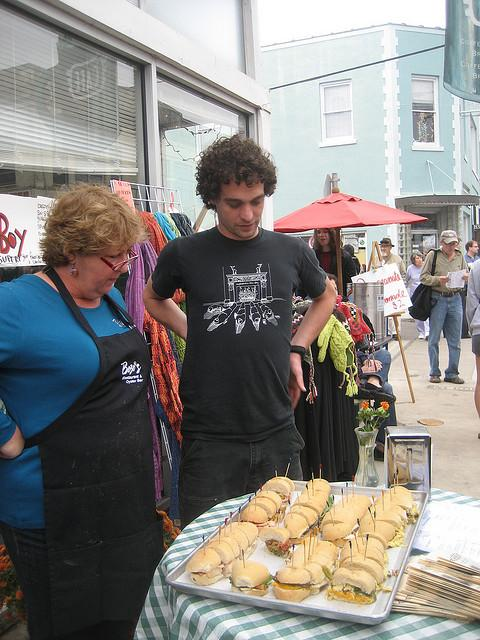What is the tray made from? metal 